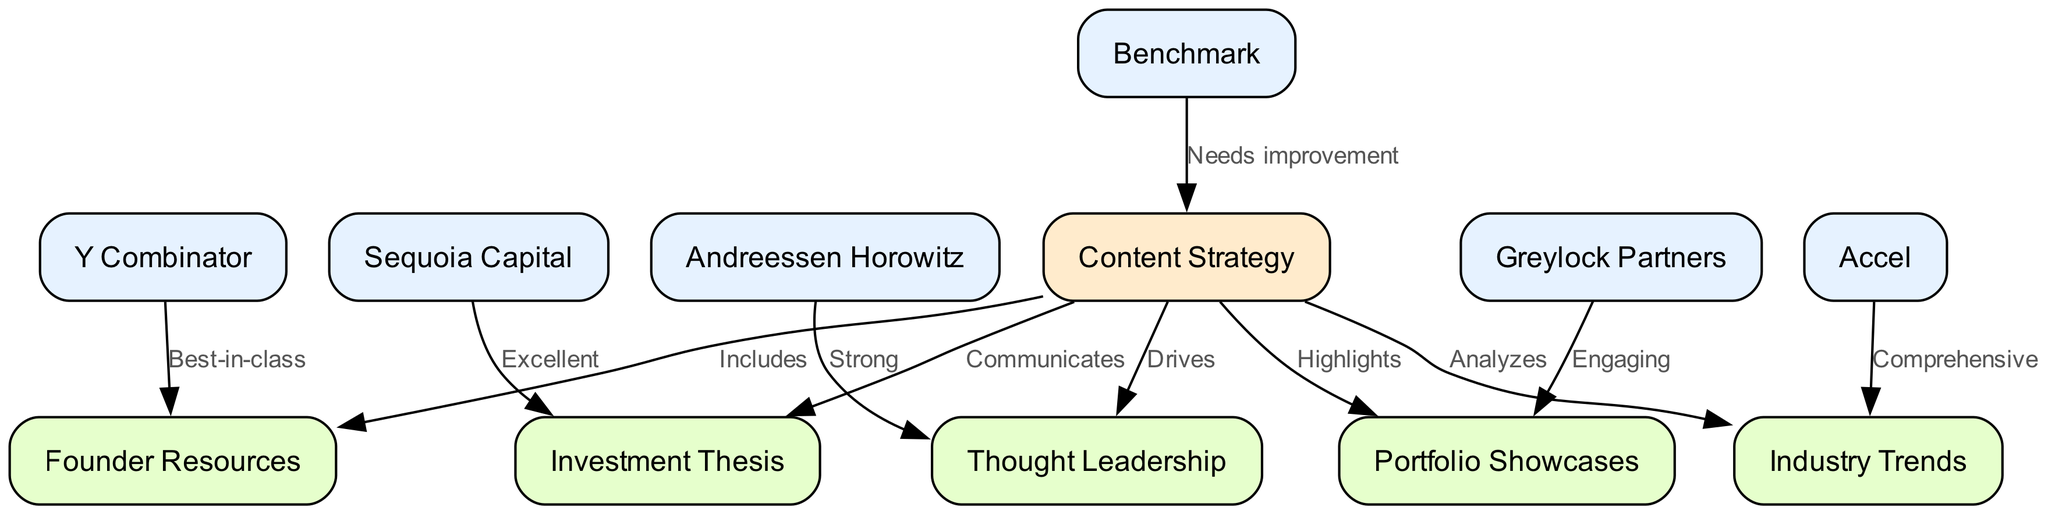What VC firm is associated with the strongest Thought Leadership? The edge labeled "Strong" leading from "Andreessen Horowitz" to "Thought Leadership" indicates that this firm is recognized for its strength in this area.
Answer: Andreessen Horowitz Which content strategy has the best relationship with Founder Resources? The edge labeled "Best-in-class" from "Y Combinator" to "Founder Resources" shows that this relationship is notable, implying strong content strategy effectiveness in this area.
Answer: Y Combinator How many VC firms are represented in the diagram? Counting the nodes that are VC firms: Andreessen Horowitz, Sequoia Capital, Y Combinator, Accel, Greylock Partners, and Benchmark gives a total of six firms.
Answer: 6 What label describes the edge from Benchmark to Content Strategy? The label "Needs improvement" is stated on the edge connecting Benchmark to Content Strategy, indicating a recognized area for growth.
Answer: Needs improvement Which VC firm has an edge labeled "Comprehensive"? The edge from "Accel" to "Industry Trends" is labeled "Comprehensive", identifying Accel as a firm with a well-rounded strategy in this area.
Answer: Accel What content area does Sequoia Capital excel in? The edge from Sequoia Capital to "Investment Thesis" is labeled "Excellent", signifying that this is the area of strength for this firm.
Answer: Investment Thesis Which strategic content area highlights Portfolio Showcases? The edge from "Content Strategy" to "Portfolio Showcases" is labeled "Highlights", suggesting that this area is an emphasis in their overall strategic content.
Answer: Portfolio Showcases What type of graph is used in this analysis? The graph is directed, as indicated by the edges showing the direction of the relationships between nodes, illustrating the connection flow clearly.
Answer: Directed Graph Which VC firm has engaging Portfolio Showcases? The edge labeled "Engaging" leading from "Greylock Partners" to "Portfolio Showcases" depicts this firm as having a noteworthy engaging quality in this content area.
Answer: Greylock Partners 